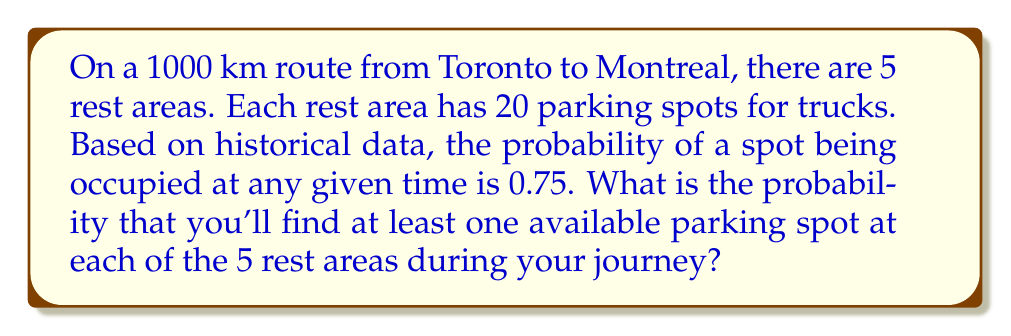What is the answer to this math problem? Let's approach this step-by-step:

1) First, we need to find the probability of at least one spot being available at a single rest area.

2) The probability of all spots being occupied in one rest area is:
   $$(0.75)^{20} = 0.0032$$

3) Therefore, the probability of at least one spot being available is:
   $$1 - (0.75)^{20} = 0.9968$$

4) Now, we need this to happen at all 5 rest areas independently. The probability of this occurring is:
   $$(0.9968)^5$$

5) Let's calculate this:
   $$(0.9968)^5 = 0.9841$$

This means there's a 98.41% chance of finding at least one available spot at each of the 5 rest areas.
Answer: 0.9841 or 98.41% 